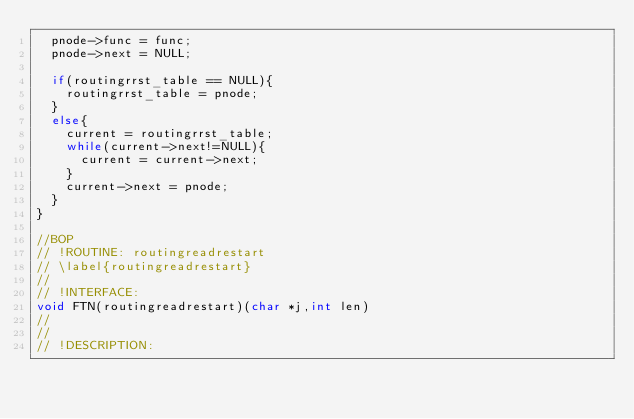<code> <loc_0><loc_0><loc_500><loc_500><_C_>  pnode->func = func;
  pnode->next = NULL; 

  if(routingrrst_table == NULL){
    routingrrst_table = pnode;
  }
  else{
    current = routingrrst_table; 
    while(current->next!=NULL){
      current = current->next;
    }
    current->next = pnode; 
  }
}

//BOP
// !ROUTINE: routingreadrestart
// \label{routingreadrestart}
//
// !INTERFACE:
void FTN(routingreadrestart)(char *j,int len)
//
//  
// !DESCRIPTION: </code> 